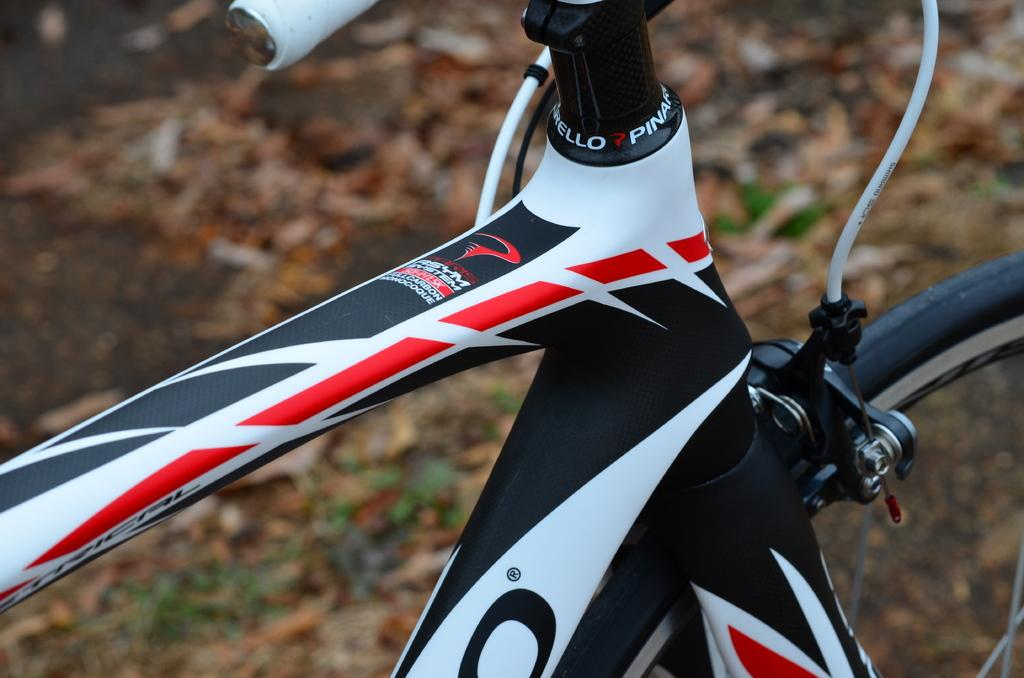What is the main object in the image? There is a bicycle in the image. What can be seen in the background of the image? The ground is visible in the background of the image. What type of attraction is present in the image? There is no attraction present in the image; it only features a bicycle and the visible ground. How many fingers can be seen pointing at the bicycle in the image? There are no fingers visible in the image, as it only features a bicycle and the visible ground. 